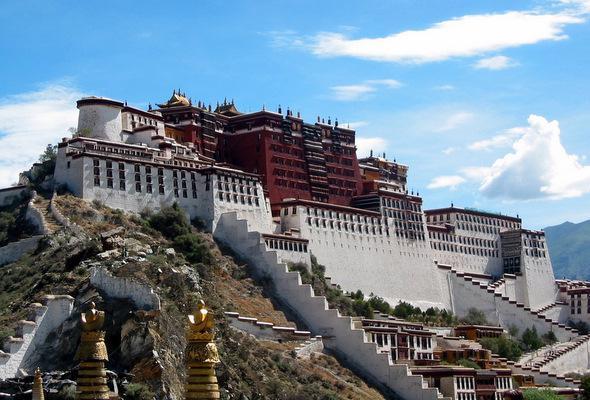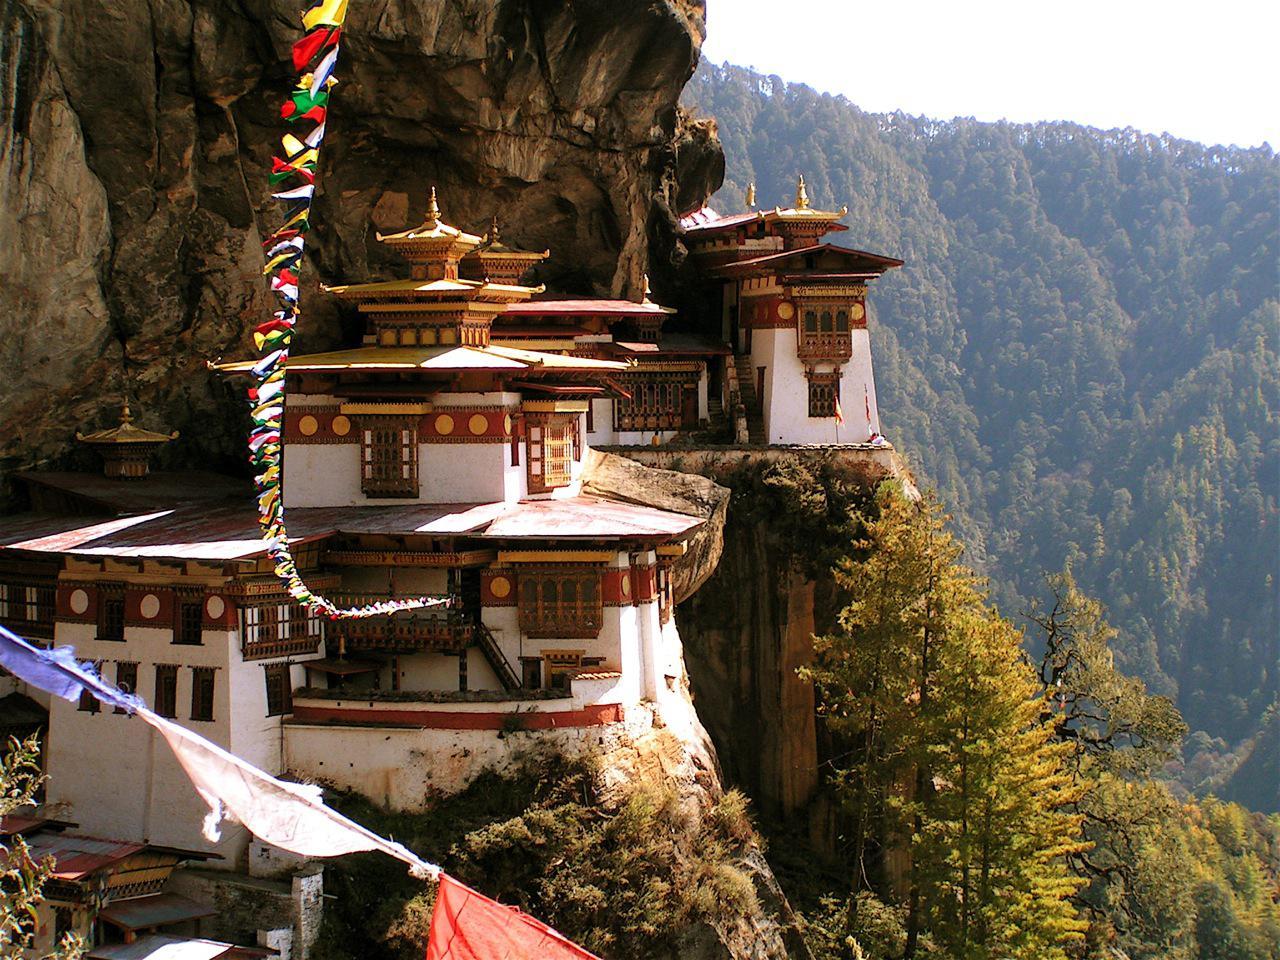The first image is the image on the left, the second image is the image on the right. Given the left and right images, does the statement "In one image, the walls running up the mountain towards a monastery are built up the steep slopes in a stair-like design." hold true? Answer yes or no. Yes. The first image is the image on the left, the second image is the image on the right. Given the left and right images, does the statement "A jagged, staircase-like wall goes up a hillside with a monastery on top, in one image." hold true? Answer yes or no. Yes. 